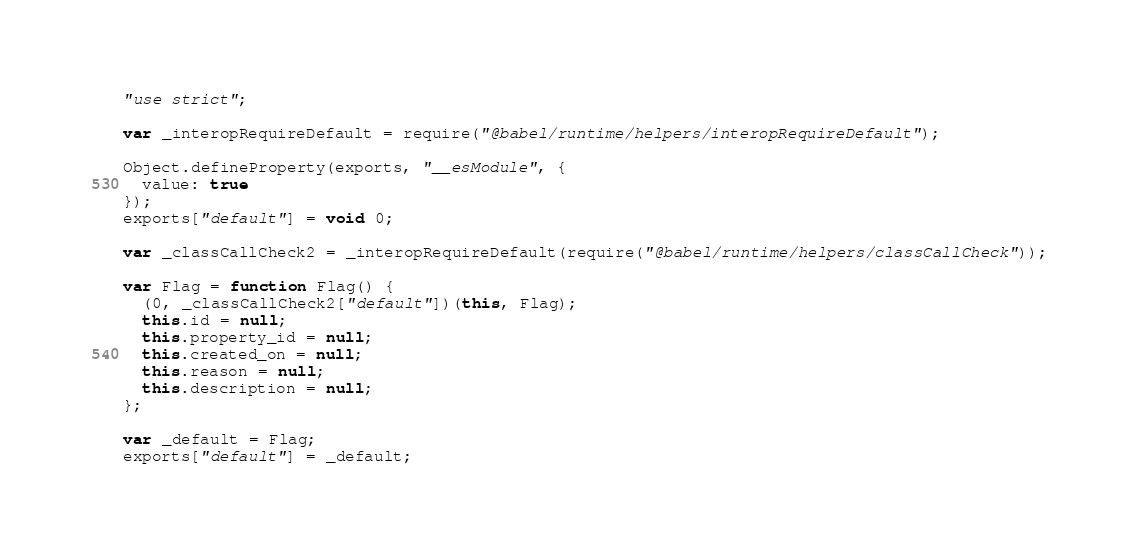<code> <loc_0><loc_0><loc_500><loc_500><_JavaScript_>"use strict";

var _interopRequireDefault = require("@babel/runtime/helpers/interopRequireDefault");

Object.defineProperty(exports, "__esModule", {
  value: true
});
exports["default"] = void 0;

var _classCallCheck2 = _interopRequireDefault(require("@babel/runtime/helpers/classCallCheck"));

var Flag = function Flag() {
  (0, _classCallCheck2["default"])(this, Flag);
  this.id = null;
  this.property_id = null;
  this.created_on = null;
  this.reason = null;
  this.description = null;
};

var _default = Flag;
exports["default"] = _default;</code> 